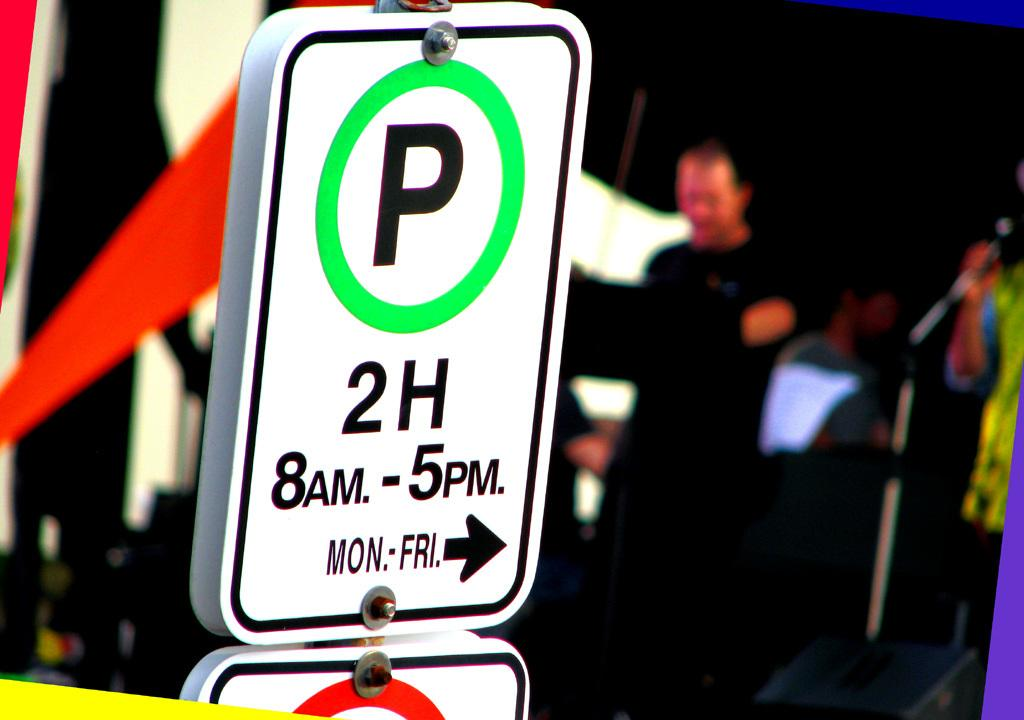<image>
Describe the image concisely. A sign that says parking is limited to 2 hours from 8 AM - 5 PM Monday through Friday. 